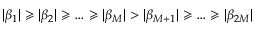Convert formula to latex. <formula><loc_0><loc_0><loc_500><loc_500>| \beta _ { 1 } | \geqslant | \beta _ { 2 } | \geqslant \dots \geqslant | \beta _ { M } | > | \beta _ { M + 1 } | \geqslant \dots \geqslant | \beta _ { 2 M } |</formula> 